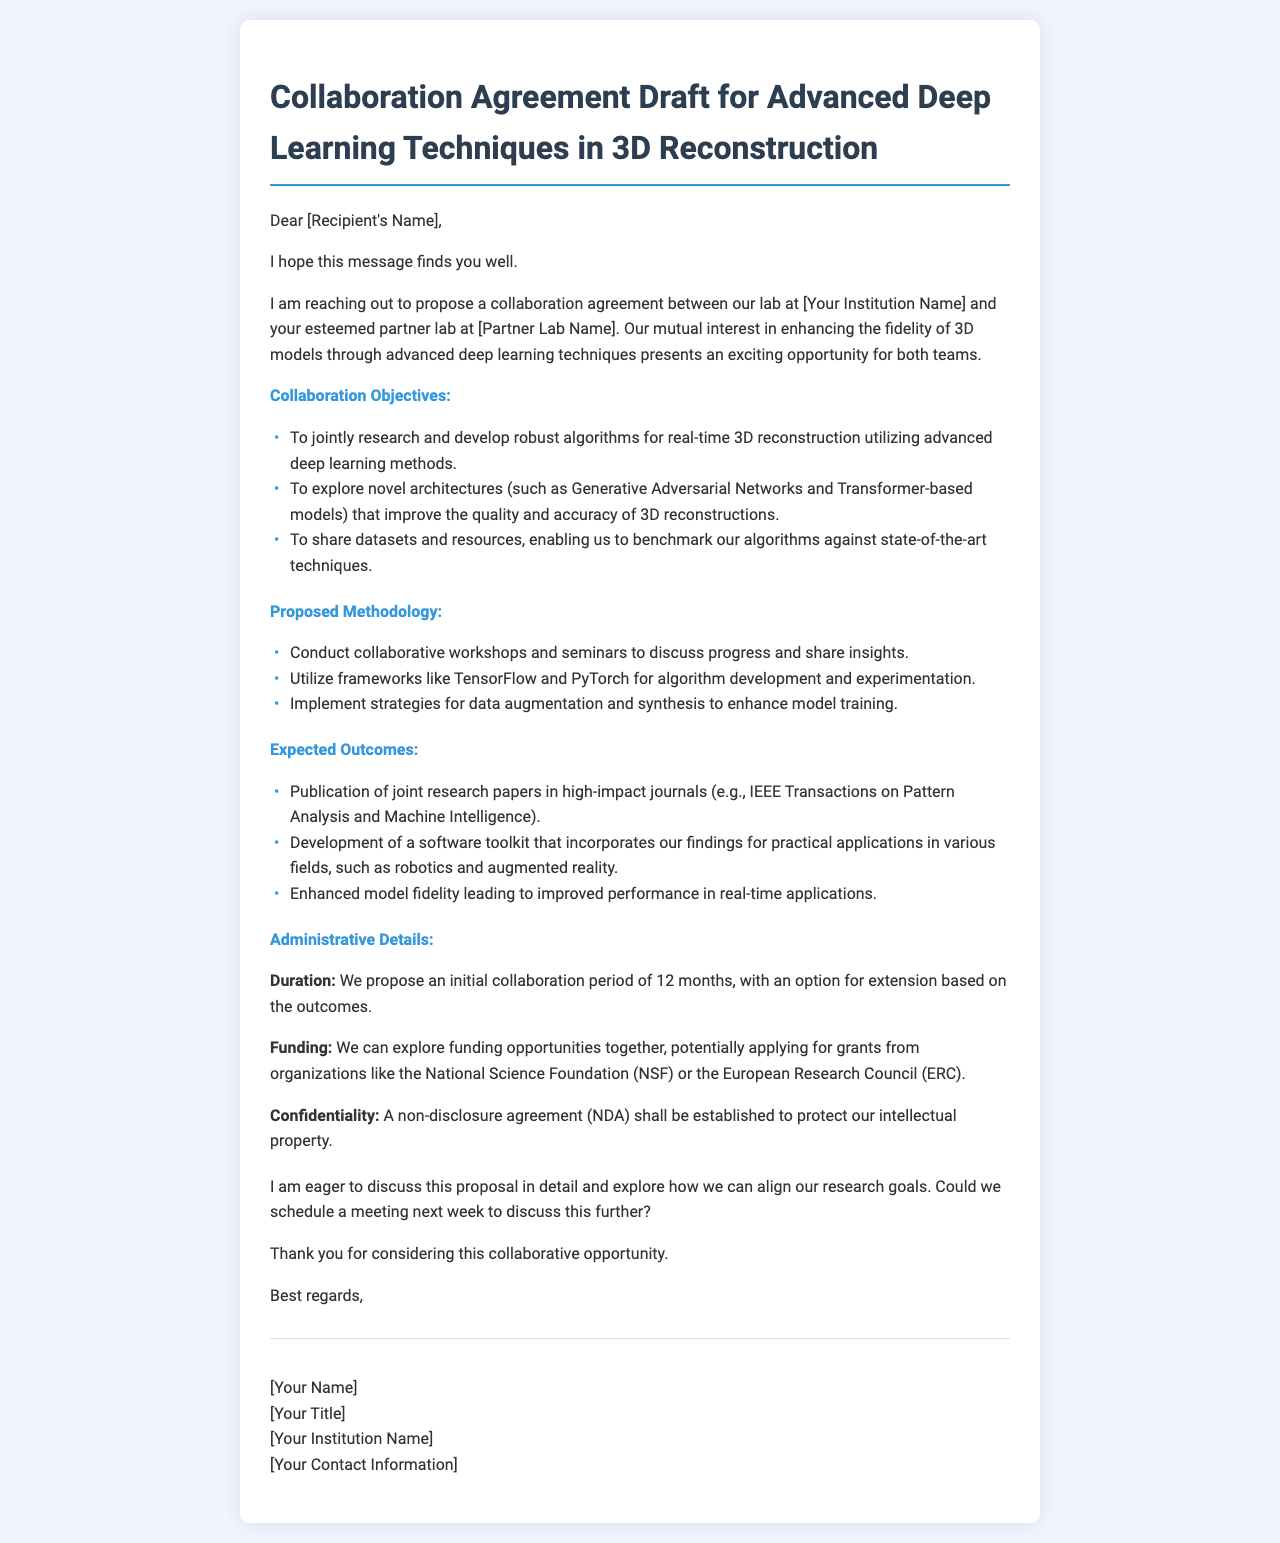What is the title of the document? The title of the document is indicated at the top of the rendered content.
Answer: Collaboration Agreement Draft for Advanced Deep Learning Techniques in 3D Reconstruction Who is proposed to collaborate with [Your Institution Name]? The document states the collaboration is proposed with [Partner Lab Name].
Answer: [Partner Lab Name] What is the initial proposed duration of the collaboration? The document mentions that the proposed duration is explicitly stated in the "Administrative Details" section.
Answer: 12 months Which deep learning methods are mentioned as a focus for the collaboration? The collaboration objectives include utilizing advanced deep learning methods, specifically indicated in the list.
Answer: Generative Adversarial Networks and Transformer-based models What type of agreement will be established to protect intellectual property? The document explicitly refers to an agreement concerning confidentiality.
Answer: Non-disclosure agreement (NDA) What is one of the expected outcomes related to publishing? The document highlights a specific expected outcome related to research publication under the "Expected Outcomes" section.
Answer: Publication of joint research papers What frameworks are proposed for algorithm development? The methodology section suggests specific frameworks for development and experimentation.
Answer: TensorFlow and PyTorch What is a potential funding organization mentioned in the draft? The draft refers to specific organizations where collaboration might seek funding within the administrative details.
Answer: National Science Foundation (NSF) 